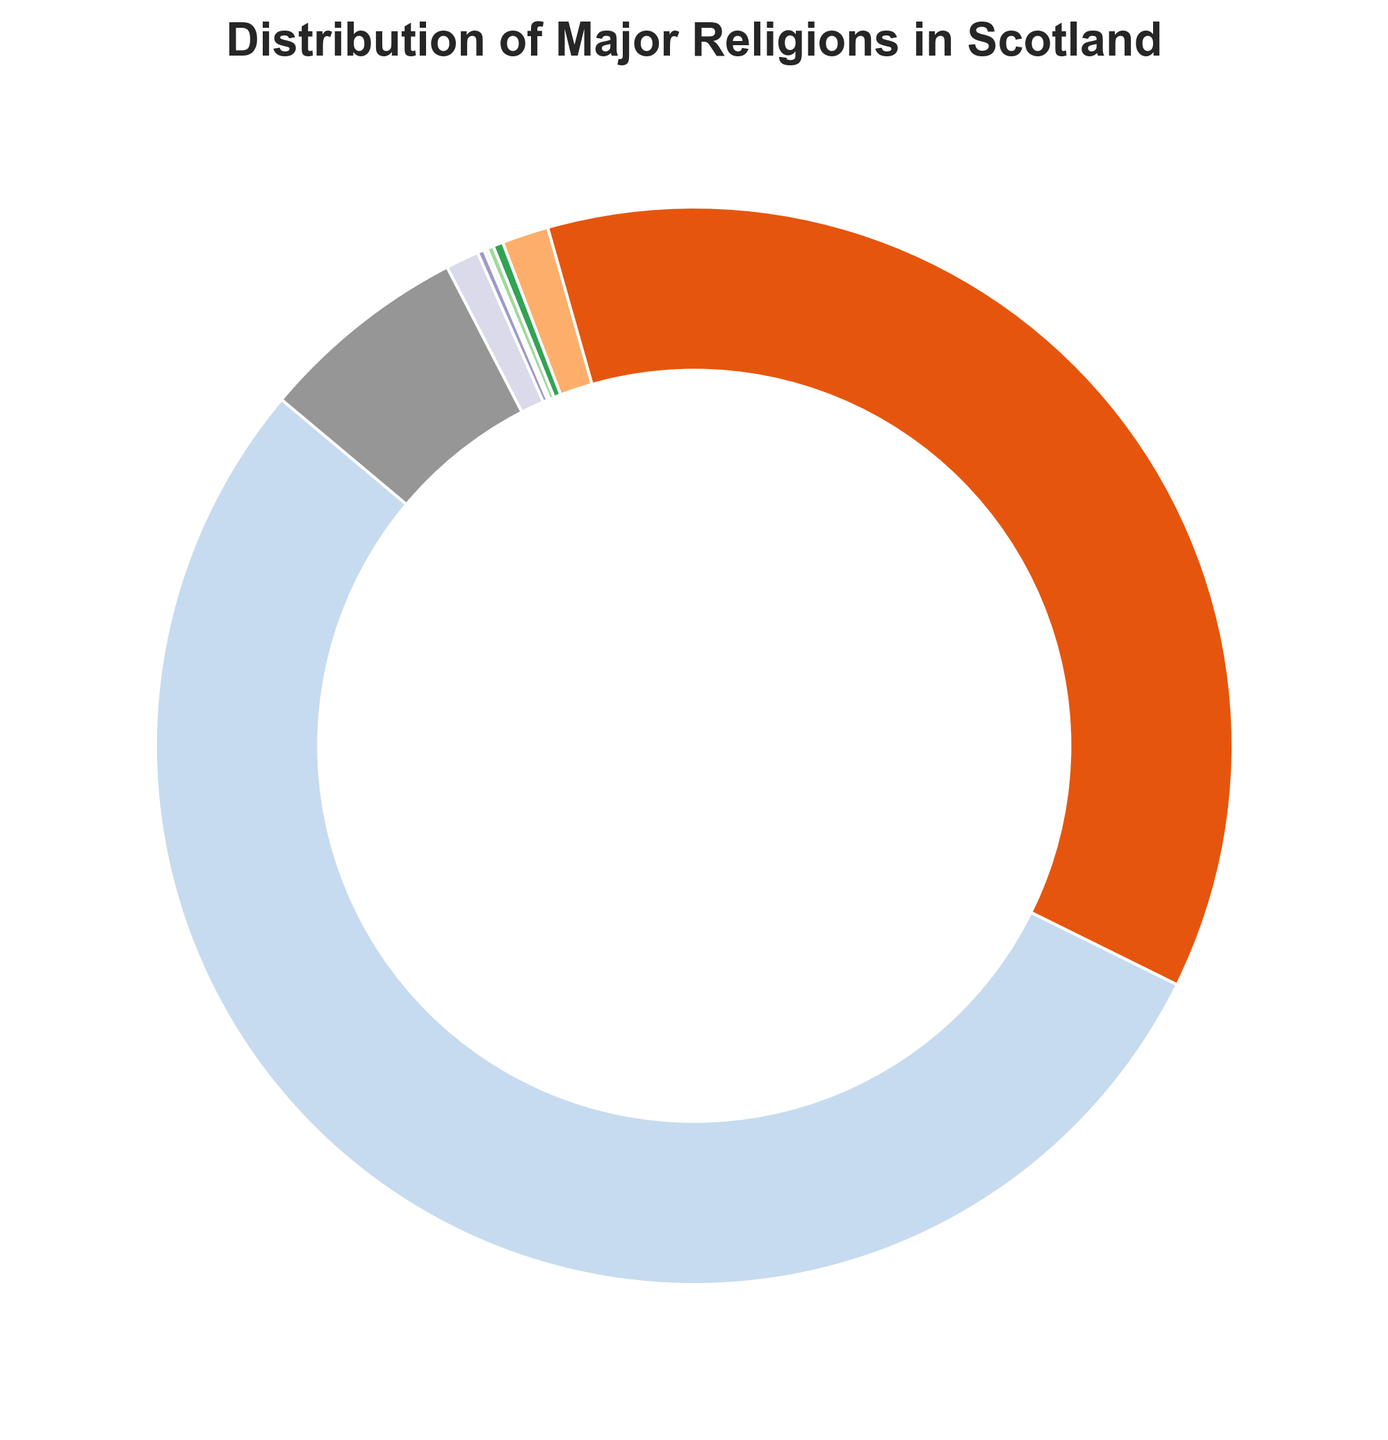What is the percentage of people in Scotland who identify as Christian? Look at the slice labeled "Christianity" on the pie chart and read the percentage value.
Answer: 53.8% Is the percentage of people with no religion higher or lower than those identifying as Christian? Compare the slices for "No Religion" and "Christianity". "No Religion" is 36.7% and "Christianity" is 53.8%.
Answer: Lower What is the total percentage of people who follow a religion other than Christianity? Sum the percentages of followers of Islam, Hinduism, Sikhism, Judaism, Buddhism, and "Other Religions": 1.4 + 0.3 + 0.2 + 0.1 + 0.2 + 1.0 = 3.2%.
Answer: 3.2% How does the size of the segment for "Not Stated" compare to "No Religion"? Compare the slices for "Not Stated" (6.3%) and "No Religion" (36.7%). The "Not Stated" slice is smaller.
Answer: Smaller What is the percentage difference between the largest and smallest religious groups? The largest group is "Christianity" (53.8%) and the smallest is "Judaism" (0.1%). The difference is 53.8 - 0.1 = 53.7%.
Answer: 53.7% Which religious group occupies the smallest segment on the pie chart? Look for the slice with the smallest percentage value, which is "Judaism" at 0.1%.
Answer: Judaism What fraction of the population does the "No Religion" group represent compared to the total population? The total pie chart represents 100%, so the fraction for "No Religion" is 36.7/100 = 0.367.
Answer: 0.367 Is the combined percentage of those who do not state their religion and those following "Other Religions" more or less than 10%? Add the percentages for "Not Stated" (6.3%) and "Other Religions" (1.0%): 6.3 + 1.0 = 7.3%.
Answer: Less How many times larger is the percentage of "Christianity" followers compared to "Islam" followers? Divide the percentage of "Christianity" followers (53.8%) by the percentage of "Islam" followers (1.4%): 53.8 / 1.4 ≈ 38.43.
Answer: 38 times larger 